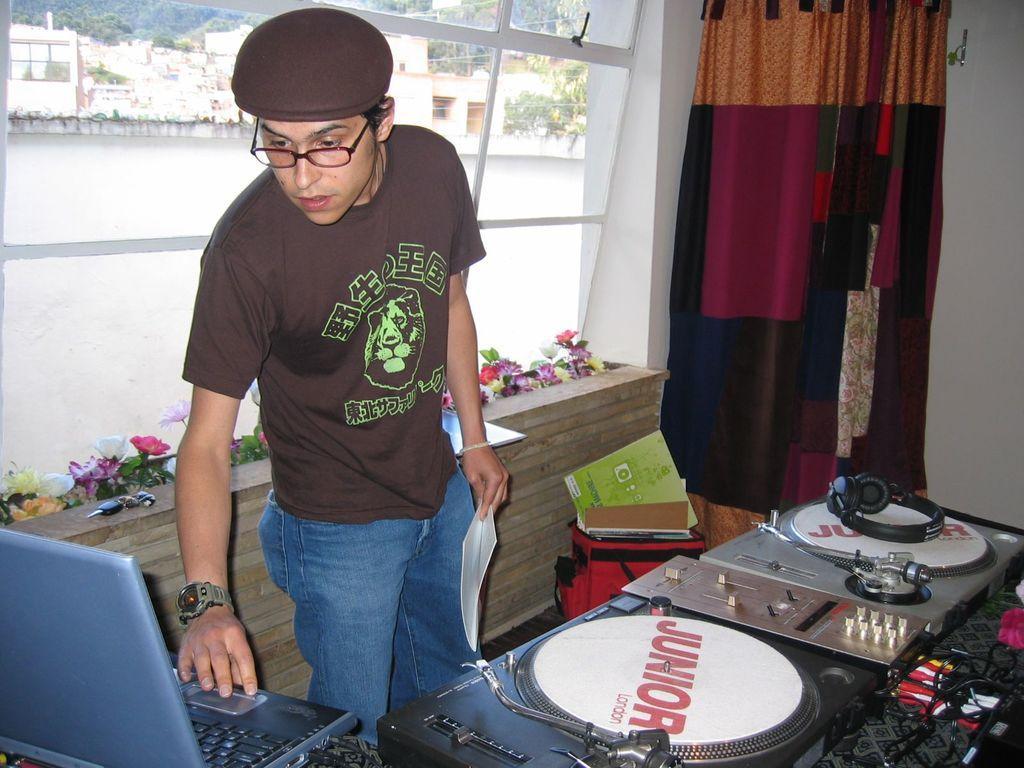Describe this image in one or two sentences. In the image we can see a man standing, wearing clothes, spectacles, cap, a wrist watch and the man is holding a paper in his hand. Here we can see the laptop, electronic devices and headsets. Here we can see glass windows and out of the window we can see trees, buildings and the water. Here we can see the flower and the curtains. 